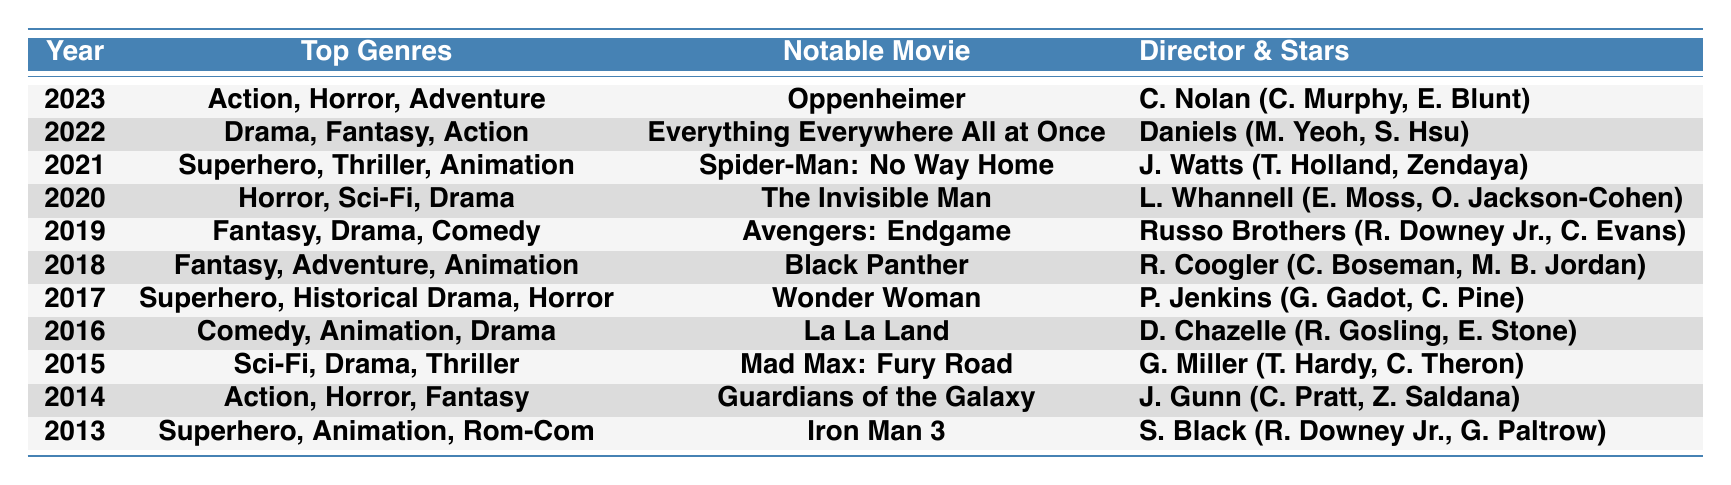What were the top genres in 2021? In the table, the entry for 2021 lists the top genres as "Superhero, Thriller, Animation."
Answer: Superhero, Thriller, Animation Which notable movie was released in 2016? Referring to the row for 2016, the notable movie listed is "La La Land."
Answer: La La Land Was "The Invisible Man" released in 2019? The table shows "The Invisible Man" under the year 2020, so it was not released in 2019.
Answer: No What is the most common genre listed across the years? Analyzing the top genres from each year, "Superhero" appears in 2013, 2017, and 2021, making it the most common.
Answer: Superhero How many years had "Animation" as one of the top genres? By counting the years (2013, 2016, 2018, and 2021) where "Animation" is listed in the top genres, it appears in 4 years.
Answer: 4 Identify the notable movies for the year 2019. The table shows the notable movies for 2019 as "Avengers: Endgame," "Joker," and "Once Upon a Time in Hollywood."
Answer: Avengers: Endgame, Joker, Once Upon a Time in Hollywood Which director helmed the most notable movies in the table? By reviewing the directors' names for notable movies, it appears that the Russo Brothers directed two notable movies in 2019; other directors have one each.
Answer: Russo Brothers What notable movies were released in the years that had "Drama" as a top genre? The years with "Drama" as a top genre are 2015, 2016, 2020, 2022, and 2019. The notable movies for these years are "Room," "La La Land," "The Invisible Man," "Everything Everywhere All at Once," and "Avengers: Endgame."
Answer: Room, La La Land, The Invisible Man, Everything Everywhere All at Once, Avengers: Endgame In which year did "Horror" appear in the top genres the most? By examining the years, "Horror" appears in 2014, 2017, and 2020, making a total of 3 occurrences.
Answer: 3 occurrences Which movie featured a character played by Tom Hardy? In the table for 2015, "Mad Max: Fury Road" features Tom Hardy as one of the main actors.
Answer: Mad Max: Fury Road 